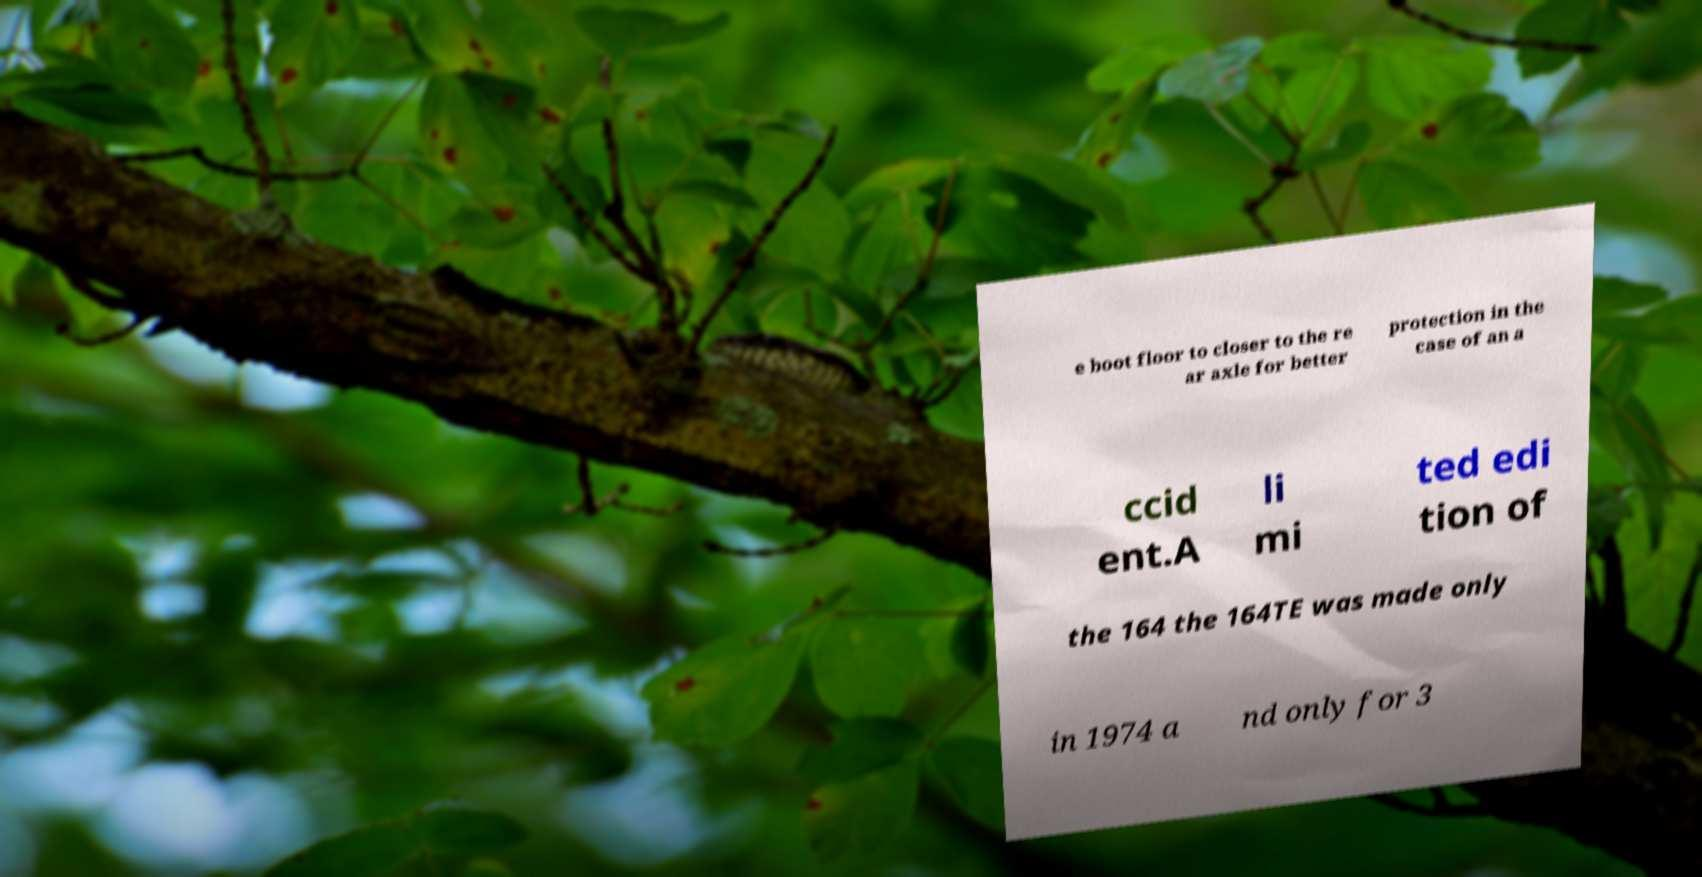Could you assist in decoding the text presented in this image and type it out clearly? e boot floor to closer to the re ar axle for better protection in the case of an a ccid ent.A li mi ted edi tion of the 164 the 164TE was made only in 1974 a nd only for 3 